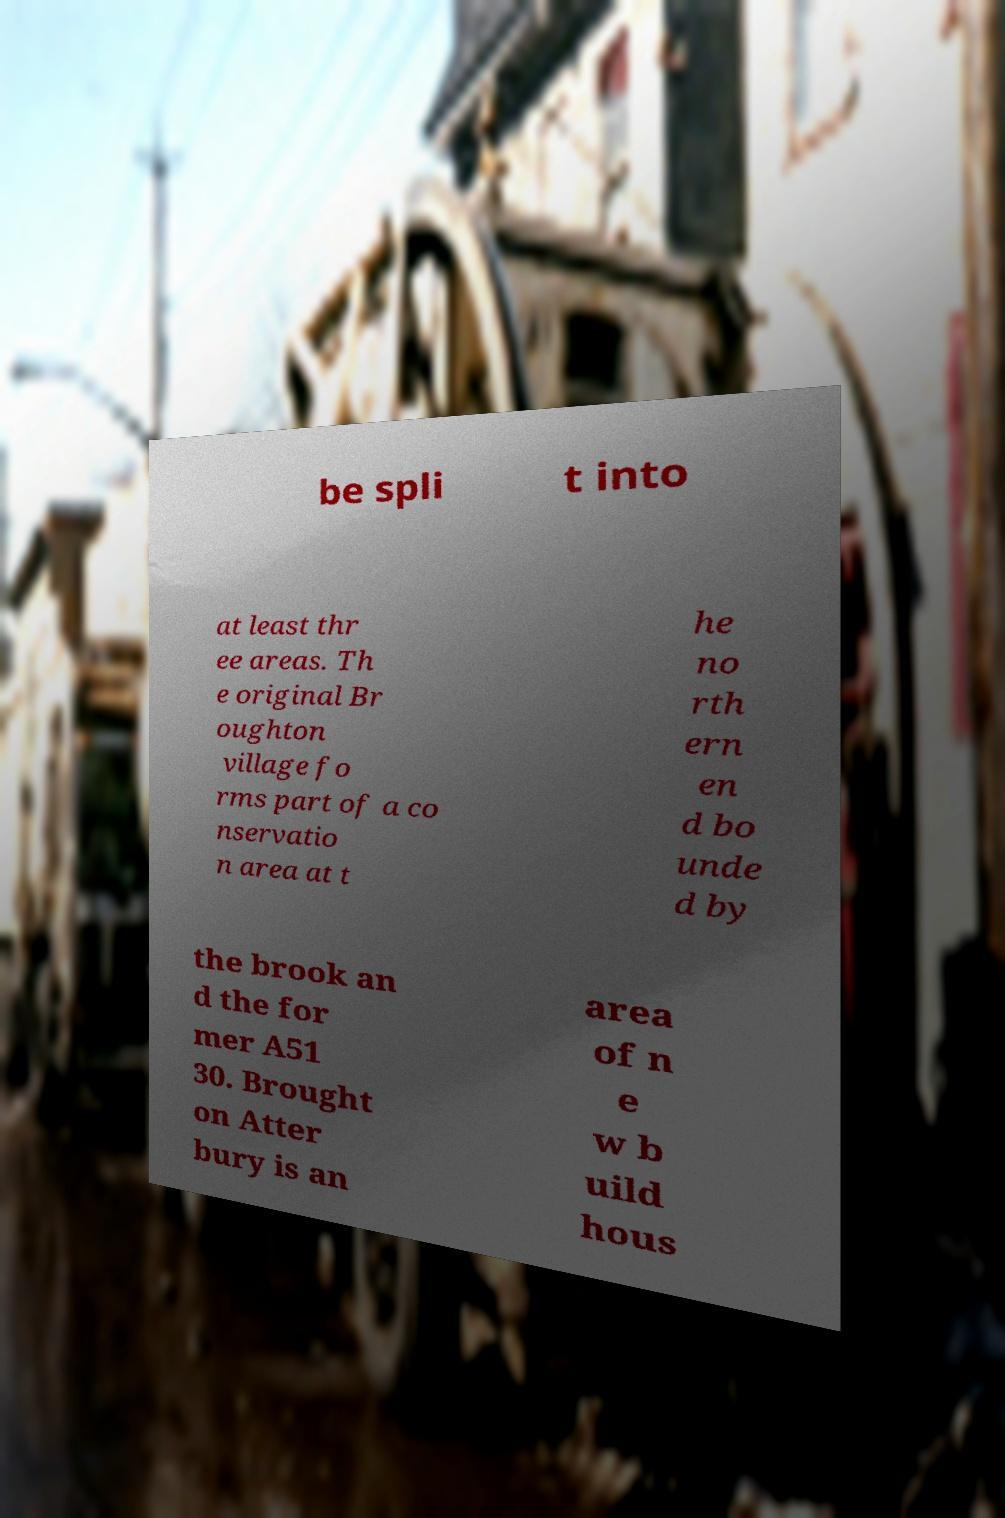There's text embedded in this image that I need extracted. Can you transcribe it verbatim? be spli t into at least thr ee areas. Th e original Br oughton village fo rms part of a co nservatio n area at t he no rth ern en d bo unde d by the brook an d the for mer A51 30. Brought on Atter bury is an area of n e w b uild hous 